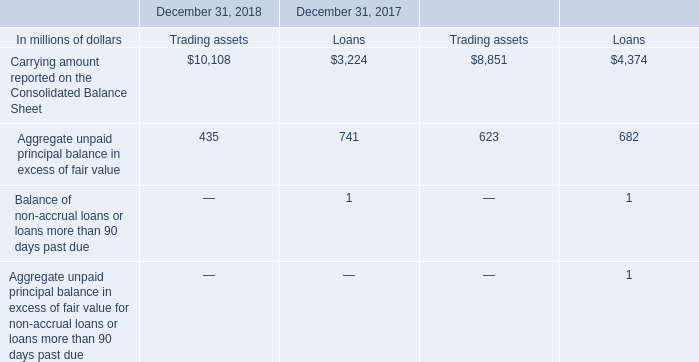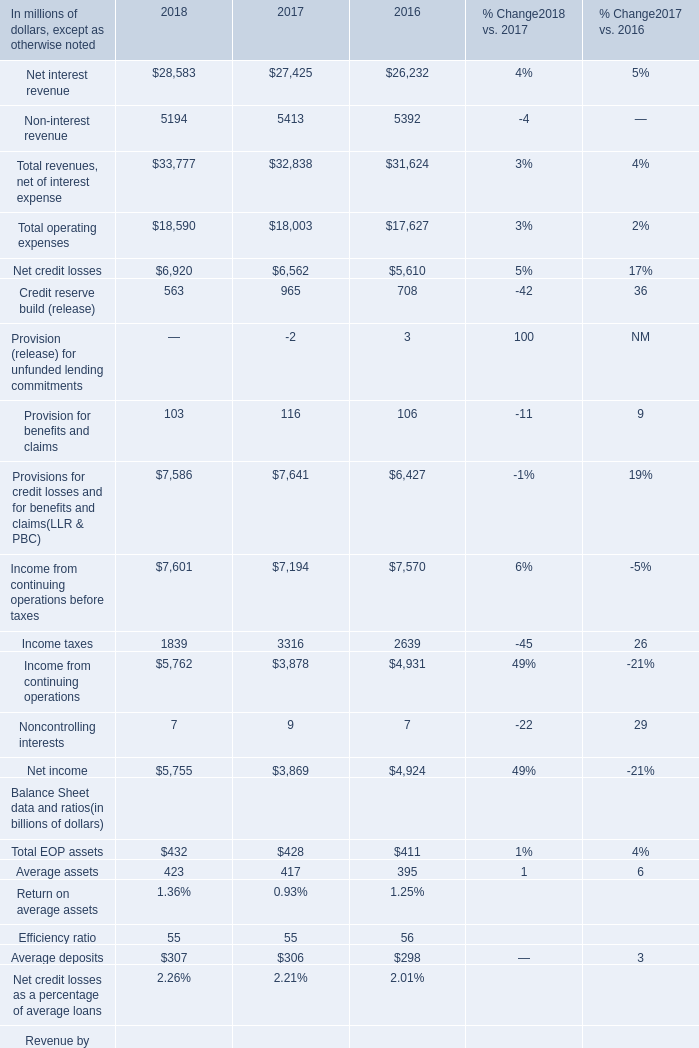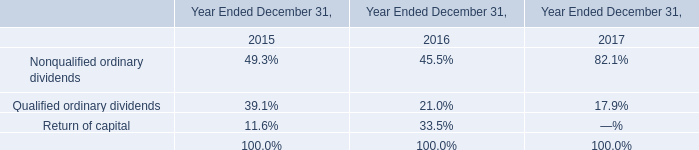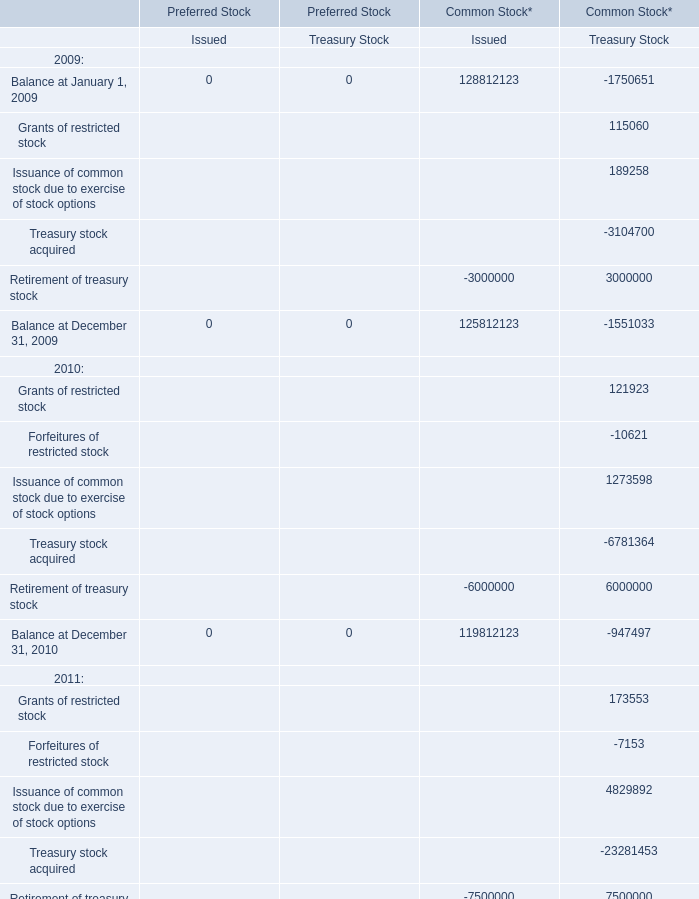In the year with largest amount of Treasury Stock , what's the sum of Retirement of treasury stock? 
Answer: 6000000. Does operating expense keeps increasing each year between 2016 and 2017? 
Answer: yes. 